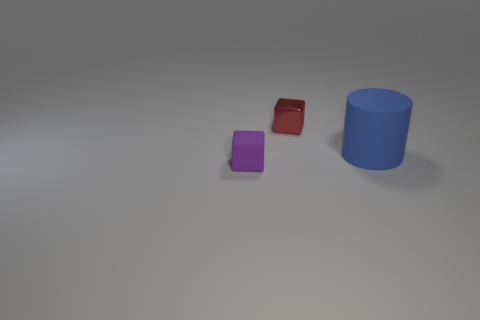Add 2 rubber blocks. How many objects exist? 5 Subtract all cylinders. How many objects are left? 2 Subtract 1 purple cubes. How many objects are left? 2 Subtract all large blue matte objects. Subtract all yellow shiny cylinders. How many objects are left? 2 Add 2 tiny red things. How many tiny red things are left? 3 Add 3 small cyan cylinders. How many small cyan cylinders exist? 3 